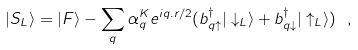<formula> <loc_0><loc_0><loc_500><loc_500>| S _ { L } \rangle = | F \rangle - \sum _ { q } \alpha ^ { K } _ { q } e ^ { i q . r / 2 } ( b ^ { \dag } _ { q \uparrow } | \downarrow _ { L } \rangle + b ^ { \dag } _ { q \downarrow } | \uparrow _ { L } \rangle ) \ ,</formula> 